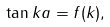<formula> <loc_0><loc_0><loc_500><loc_500>\tan k a = f ( k ) ,</formula> 